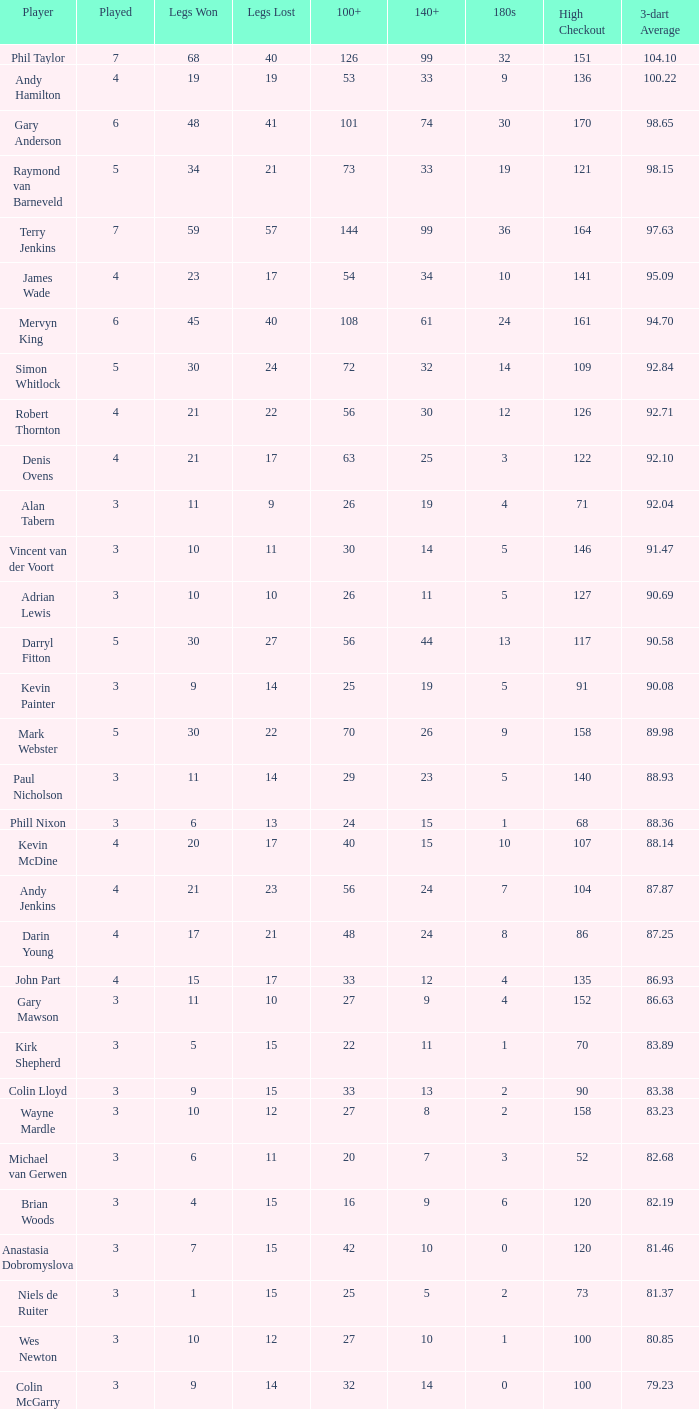Calculate the 3-dart average when there are more than 41 legs lost and over 7 legs played. 0.0. 